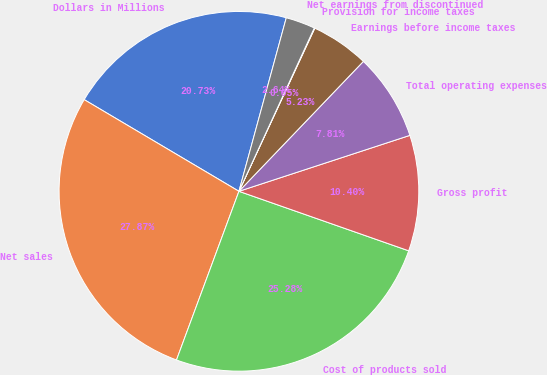Convert chart to OTSL. <chart><loc_0><loc_0><loc_500><loc_500><pie_chart><fcel>Dollars in Millions<fcel>Net sales<fcel>Cost of products sold<fcel>Gross profit<fcel>Total operating expenses<fcel>Earnings before income taxes<fcel>Provision for income taxes<fcel>Net earnings from discontinued<nl><fcel>20.73%<fcel>27.87%<fcel>25.28%<fcel>10.4%<fcel>7.81%<fcel>5.23%<fcel>0.05%<fcel>2.64%<nl></chart> 